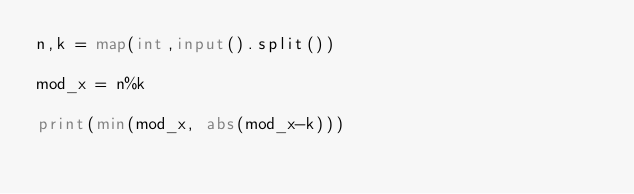Convert code to text. <code><loc_0><loc_0><loc_500><loc_500><_Python_>n,k = map(int,input().split())

mod_x = n%k

print(min(mod_x, abs(mod_x-k)))</code> 